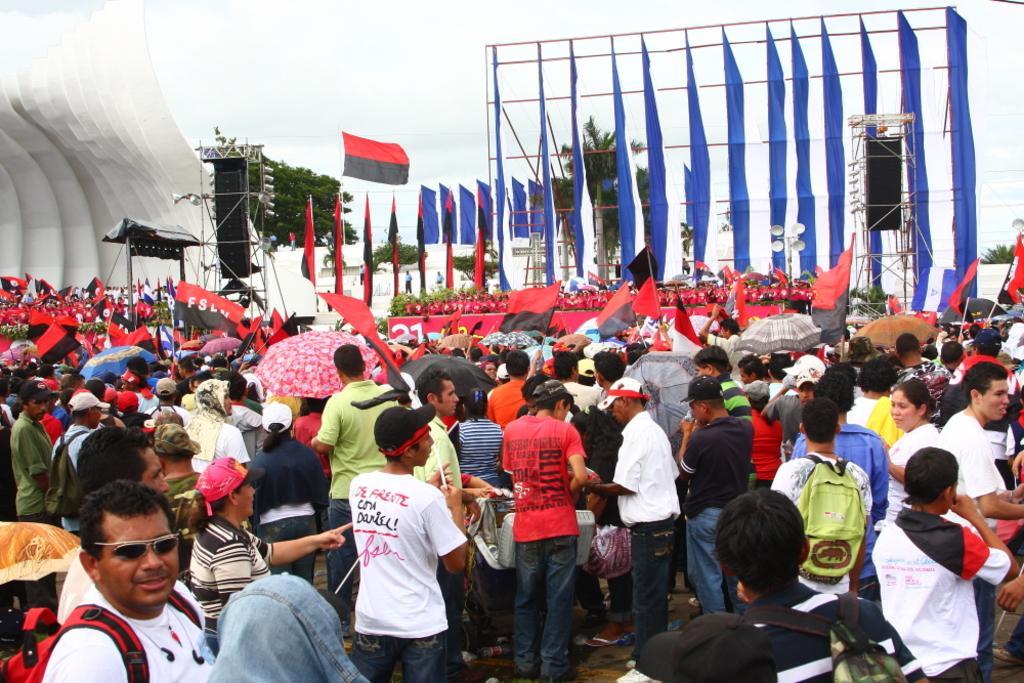Could you give a brief overview of what you see in this image? In this image I can see the group of people standing and wearing the different color dresses. And I can see few people are holding the flags which are in red and black color. In the back I can see the stage and the sound boxes. I can also see many trees and the sky in the back. 